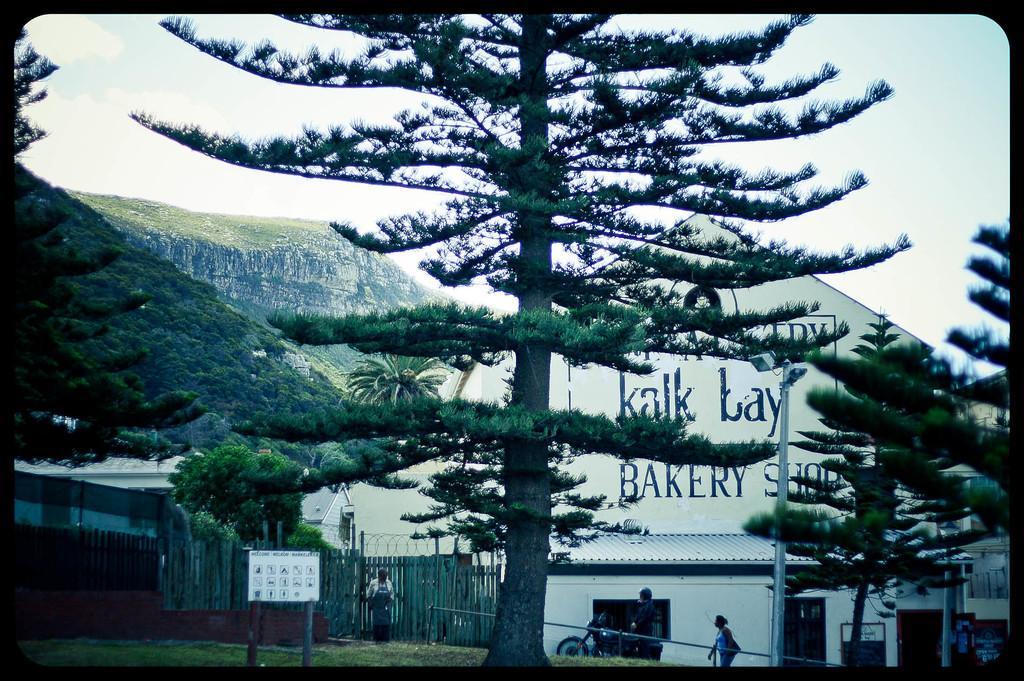Describe this image in one or two sentences. In this image in front there is a board. Behind the board there are people. There are trees, buildings, metal fence, street lights. In the background of the image there is sky. 